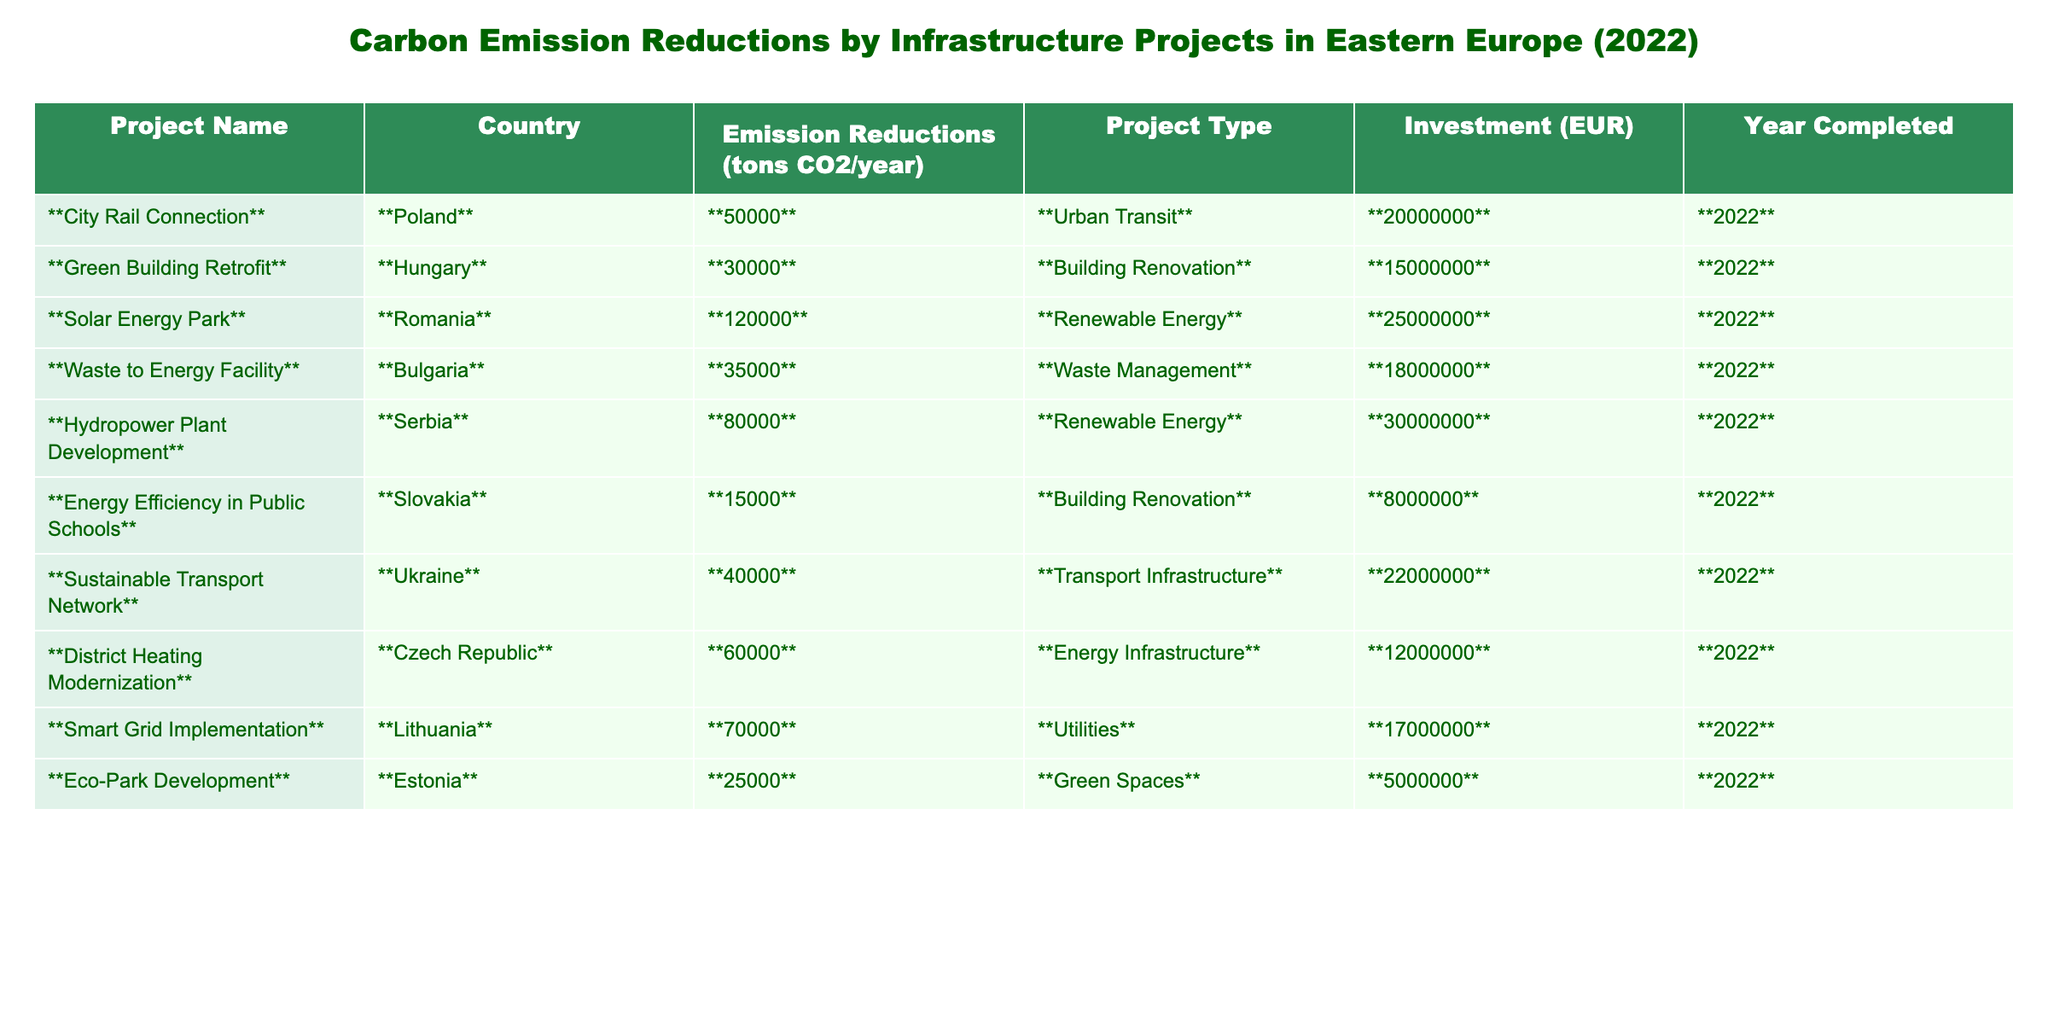What is the total carbon emission reduction from all the projects? To find the total carbon emission reduction, I add the emission reductions from each project: 50000 + 30000 + 120000 + 35000 + 80000 + 15000 + 40000 + 60000 + 70000 + 25000 =  400000 tons CO2/year.
Answer: 400000 tons CO2/year Which project had the highest investment? By examining the investment values, I can see that the Hydropower Plant Development in Serbia has the highest investment amount of 30000000 EUR.
Answer: Hydropower Plant Development How many projects were focused on renewable energy? There are two projects indicated as renewable energy: the Solar Energy Park in Romania and the Hydropower Plant Development in Serbia.
Answer: 2 projects What is the average carbon emission reduction per project? To find the average, I sum up the emission reductions (400000 tons CO2/year) and divide by the number of projects (10): 400000 / 10 = 40000 tons CO2/year.
Answer: 40000 tons CO2/year Did any project reduce more than 100,000 tons of CO2 annually? By checking the emission reduction values, no project reduced more than 100,000 tons CO2/year. The maximum is 120,000 tons from the Solar Energy Park, which is not above this threshold.
Answer: No Which country had the second least carbon emission reduction? I will list out the emissions: 15000 (Slovakia), 25000 (Estonia), 30000 (Hungary), and so on. From this analysis, the second least is Hungary with 30000 tons.
Answer: Hungary What is the total investment for projects in renewable energy? The renewable energy projects are the Solar Energy Park (25000000 EUR) and the Hydropower Plant Development (30000000 EUR). Summing these gives 25000000 + 30000000 = 55000000 EUR.
Answer: 55000000 EUR Is there a project that focuses on building renovation? Yes, there are two projects focused on building renovation: the Green Building Retrofit in Hungary and Energy Efficiency in Public Schools in Slovakia.
Answer: Yes Which project had the least carbon emission reduction and what was the investment? The project with the least emission reduction is the Energy Efficiency in Public Schools, which reduced 15000 tons of CO2, and had an investment of 8000000 EUR.
Answer: 15000 tons, 8000000 EUR What is the difference in emission reductions between the highest and lowest projects? The highest emission reduction is 120000 tons from Solar Energy Park and the lowest is 15000 from Energy Efficiency in Public Schools. The difference is 120000 - 15000 = 105000 tons CO2/year.
Answer: 105000 tons CO2/year 